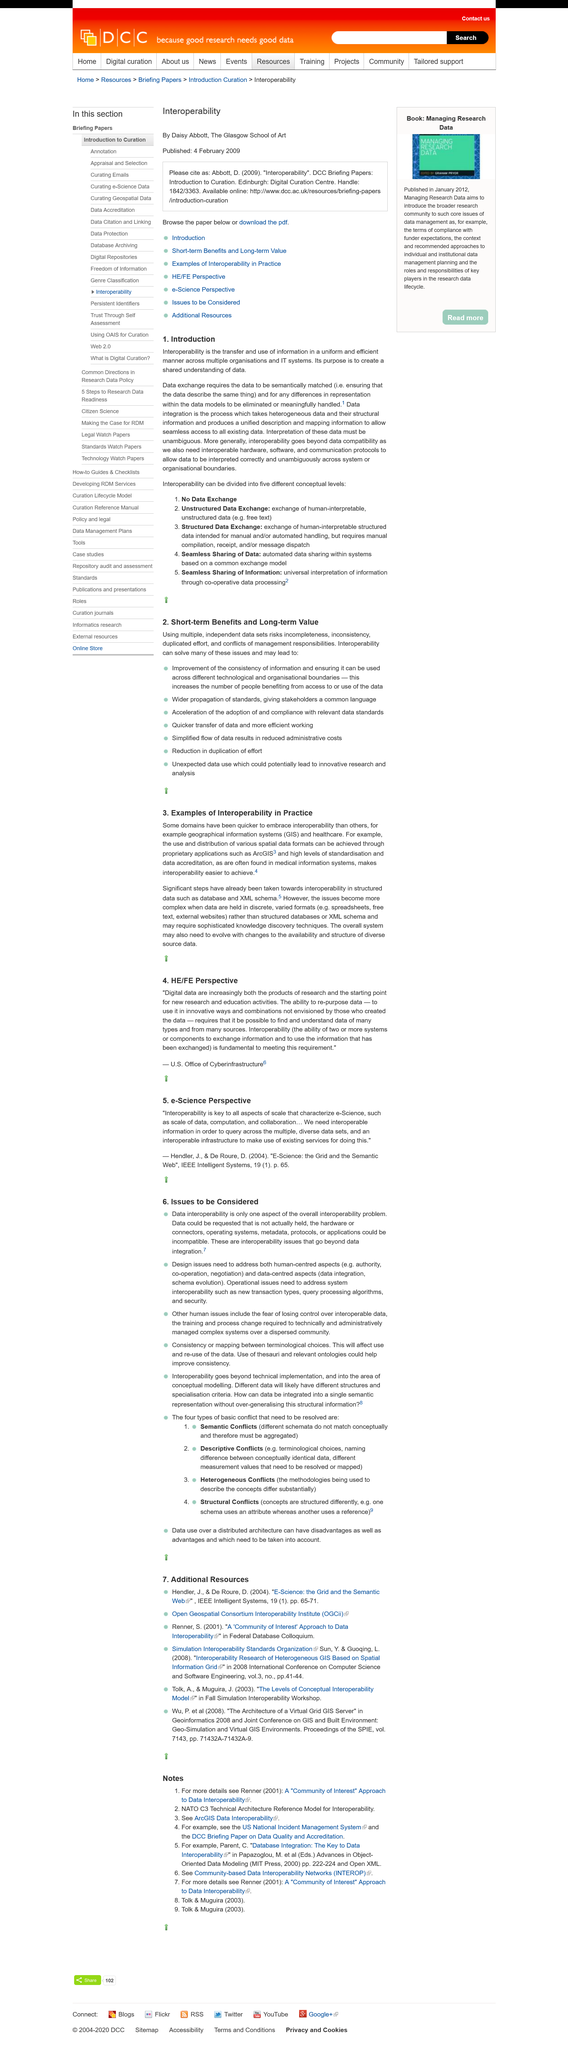List a handful of essential elements in this visual. The interpretation of data must be unambiguous, as stated by the original text. The goal of creating a shared understanding of data includes semantically matching data to achieve a shared understanding. Interoperability goes beyond data compatibility and comprises the ability of different systems and technologies to exchange and make use of information. 